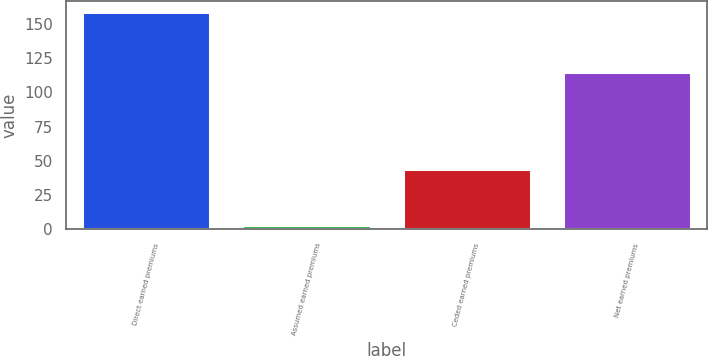<chart> <loc_0><loc_0><loc_500><loc_500><bar_chart><fcel>Direct earned premiums<fcel>Assumed earned premiums<fcel>Ceded earned premiums<fcel>Net earned premiums<nl><fcel>159<fcel>3.27<fcel>44<fcel>115<nl></chart> 